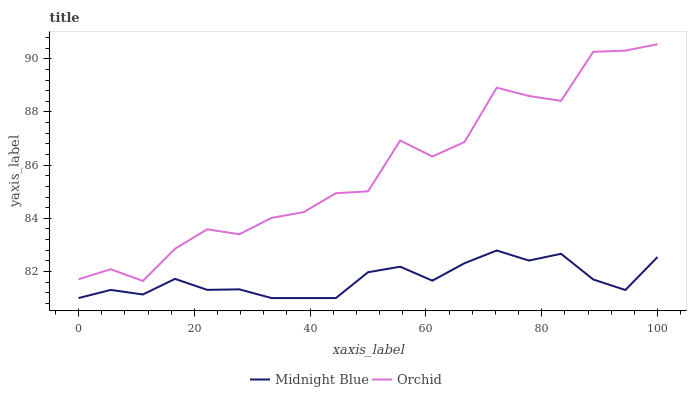Does Midnight Blue have the minimum area under the curve?
Answer yes or no. Yes. Does Orchid have the maximum area under the curve?
Answer yes or no. Yes. Does Orchid have the minimum area under the curve?
Answer yes or no. No. Is Midnight Blue the smoothest?
Answer yes or no. Yes. Is Orchid the roughest?
Answer yes or no. Yes. Is Orchid the smoothest?
Answer yes or no. No. Does Orchid have the lowest value?
Answer yes or no. No. Is Midnight Blue less than Orchid?
Answer yes or no. Yes. Is Orchid greater than Midnight Blue?
Answer yes or no. Yes. Does Midnight Blue intersect Orchid?
Answer yes or no. No. 